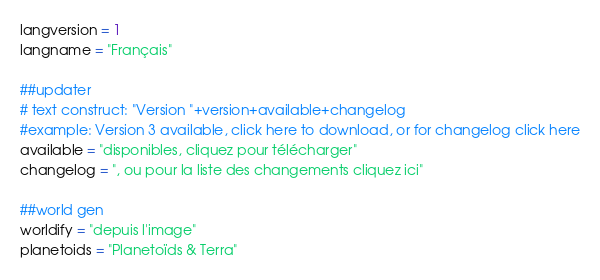<code> <loc_0><loc_0><loc_500><loc_500><_Python_>langversion = 1
langname = "Français"

##updater
# text construct: "Version "+version+available+changelog
#example: Version 3 available, click here to download, or for changelog click here
available = "disponibles, cliquez pour télécharger"
changelog = ", ou pour la liste des changements cliquez ici"

##world gen
worldify = "depuis l'image"
planetoids = "Planetoïds & Terra"</code> 